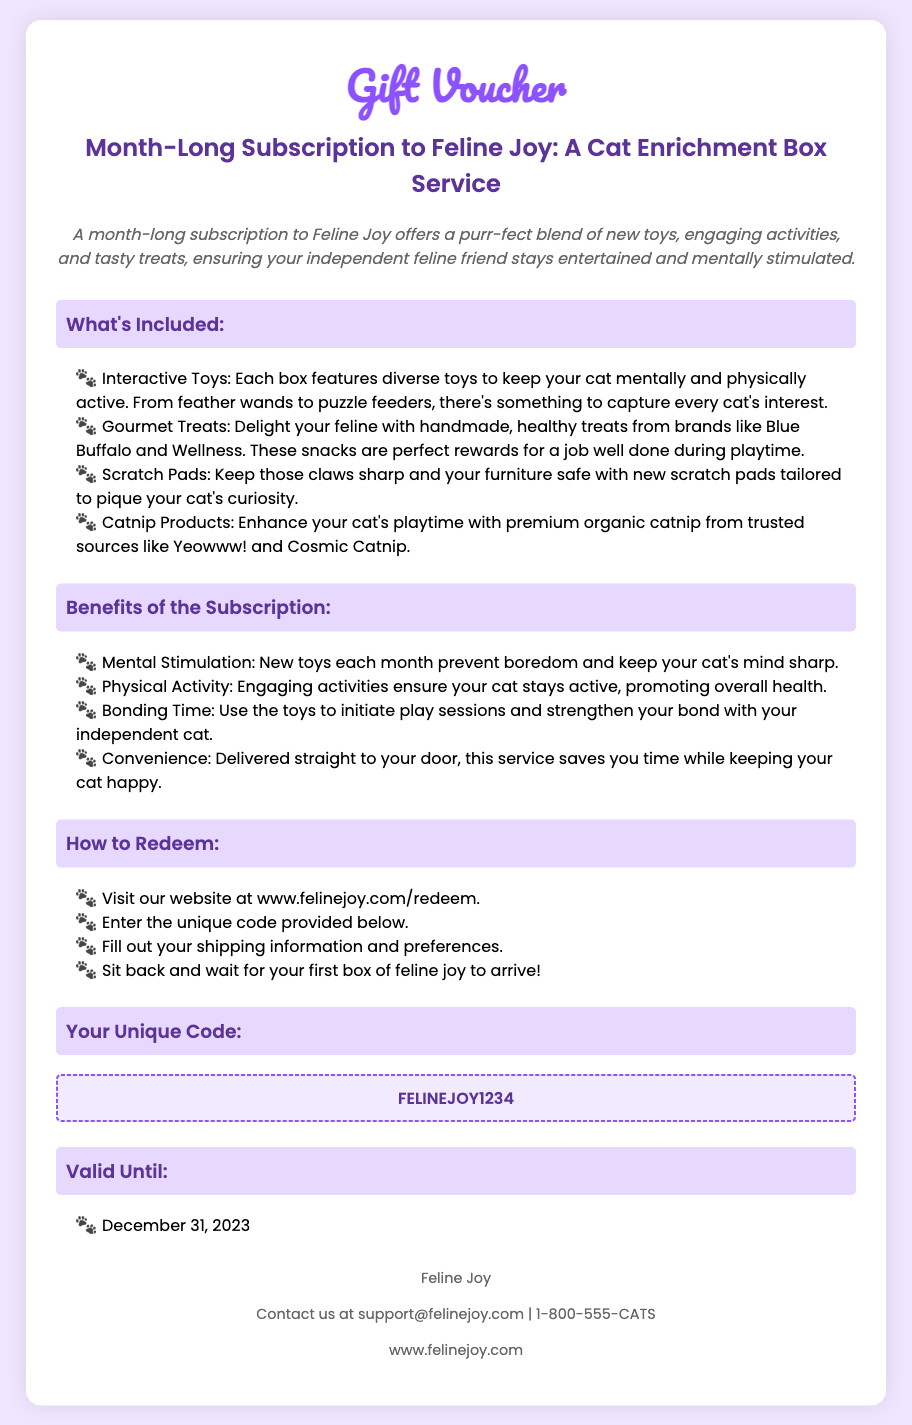What is the title of the voucher? The title of the voucher is featured at the top of the document as "Gift Voucher".
Answer: Gift Voucher What are the gourmet treats brands mentioned? The document lists two brands associated with the gourmet treats: Blue Buffalo and Wellness.
Answer: Blue Buffalo and Wellness What is the unique code to redeem the voucher? The unique code is stated in a specific section labeled for it.
Answer: FELINEJOY1234 When does this voucher expire? The expiration date is clearly indicated under the "Valid Until" section.
Answer: December 31, 2023 What type of products are included for scratching? The document specifically highlights scratch pads as part of the subscription offerings.
Answer: Scratch Pads What is a key benefit of the subscription regarding inactivity? The subscription prevents boredom for cats by providing new toys each month.
Answer: Mental Stimulation How can the voucher be redeemed? The document provides step-by-step instructions for redemption starting with a website visit.
Answer: www.felinejoy.com/redeem What is the contact email for Feline Joy? The contact information includes an email address provided in the footer of the document.
Answer: support@felinejoy.com 